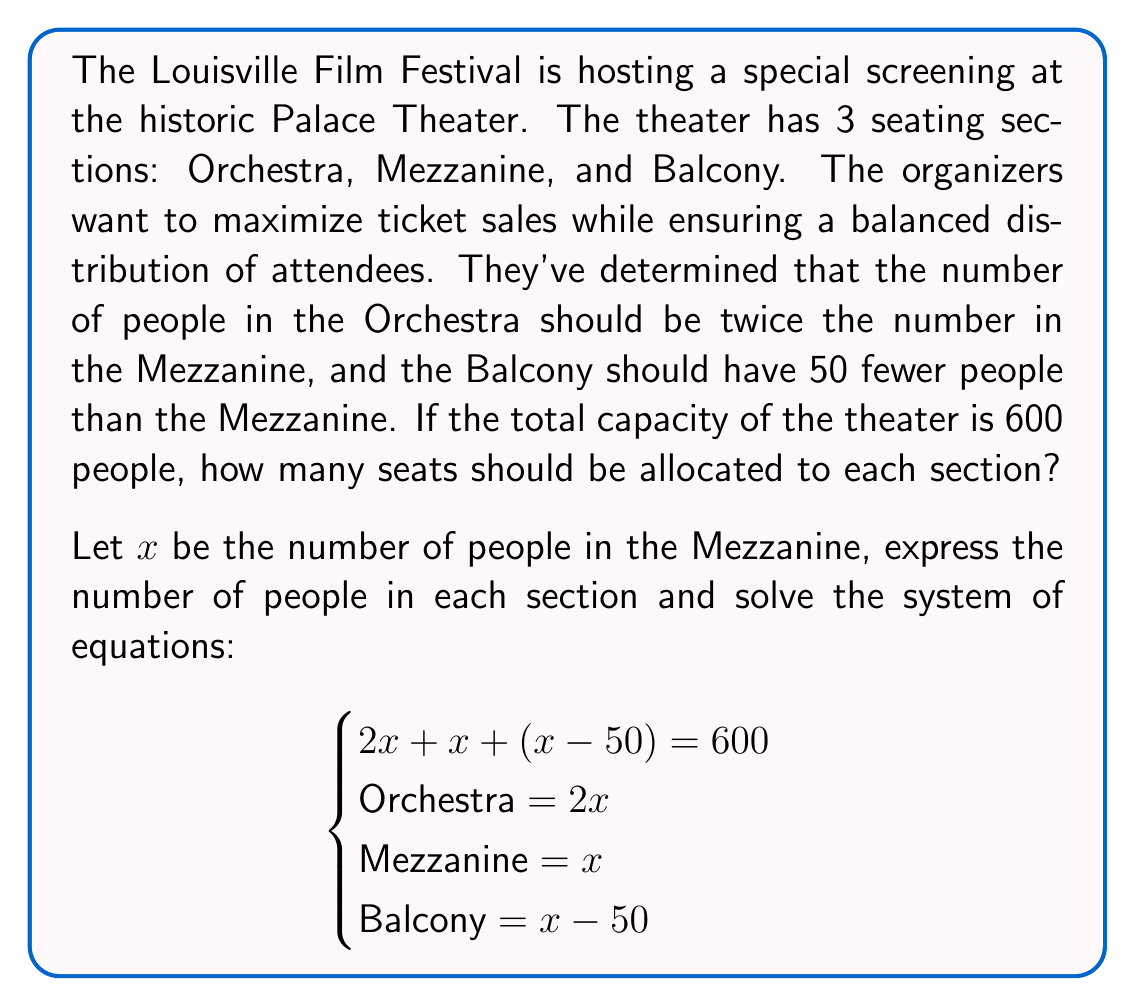Show me your answer to this math problem. Let's solve this step-by-step:

1) We start with the equation representing the total capacity:
   $2x + x + (x - 50) = 600$

2) Simplify the left side of the equation:
   $4x - 50 = 600$

3) Add 50 to both sides:
   $4x = 650$

4) Divide both sides by 4:
   $x = 162.5$

5) Since we can't have fractional people, we need to round to the nearest whole number:
   $x = 163$ (Mezzanine)

6) Now we can calculate the other sections:
   Orchestra: $2x = 2(163) = 326$
   Balcony: $x - 50 = 163 - 50 = 113$

7) Let's verify the total:
   $326 + 163 + 113 = 602$

   This is the closest we can get to 600 while maintaining whole numbers and the given ratios.
Answer: Orchestra: 326, Mezzanine: 163, Balcony: 113 